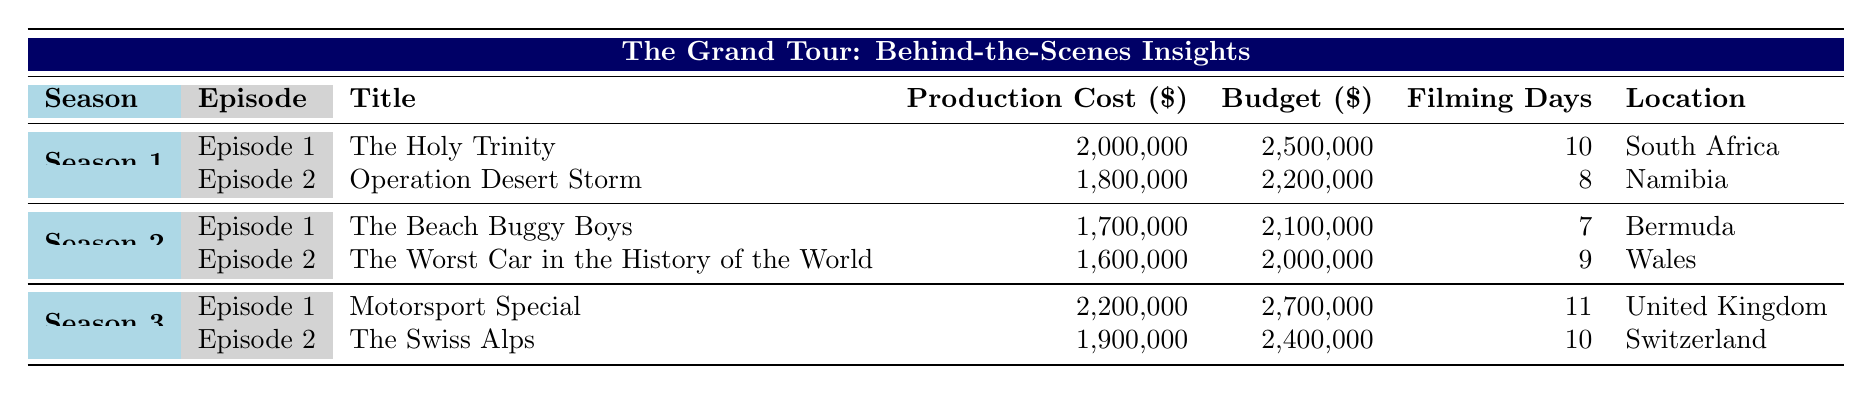What is the title of Episode 1 in Season 1? From the table, we can directly locate Season 1 and find Episode 1, which shows that the title is "The Holy Trinity."
Answer: The Holy Trinity What is the production cost of "The Beach Buggy Boys"? Looking under Season 2 and Episode 1, the production cost for "The Beach Buggy Boys" is listed as 1,700,000 dollars.
Answer: 1,700,000 How many filming days did "The Swiss Alps" have? By checking Season 3, Episode 2, we see that "The Swiss Alps" was filmed over 10 days.
Answer: 10 What is the total budget for both episodes in Season 1? We take the budget for each episode in Season 1: 2,500,000 (Episode 1) + 2,200,000 (Episode 2) = 4,700,000 dollars total.
Answer: 4,700,000 Was the production cost for "Operation Desert Storm" greater than the budget for "The Worst Car in the History of the World"? The production cost for "Operation Desert Storm" is 1,800,000, and the budget for "The Worst Car in the History of the World" is 2,000,000. Since 1,800,000 is less than 2,000,000, the statement is false.
Answer: No Which season had the highest budget for an individual episode, and what is that budget? Examining all three seasons, Season 3, Episode 1 has the highest budget of 2,700,000 dollars.
Answer: Season 3, 2,700,000 How many more filming days did "Motorsport Special" take compared to "The Worst Car in the History of the World"? "Motorsport Special" had 11 filming days and "The Worst Car in the History of the World" had 9 days. The difference is 11 - 9 = 2 days.
Answer: 2 days Is "Bermuda" a filming location for an episode in Season 3? Checking the table, "Bermuda" is listed under Season 2 for "The Beach Buggy Boys," but it is not present as a filming location for any Episode of Season 3. Thus, the answer is no.
Answer: No What are the featured cars in Episode 1 of Season 3? In the table for Season 3, Episode 1, the featured cars are listed as "Formula E Race Cars."
Answer: Formula E Race Cars 